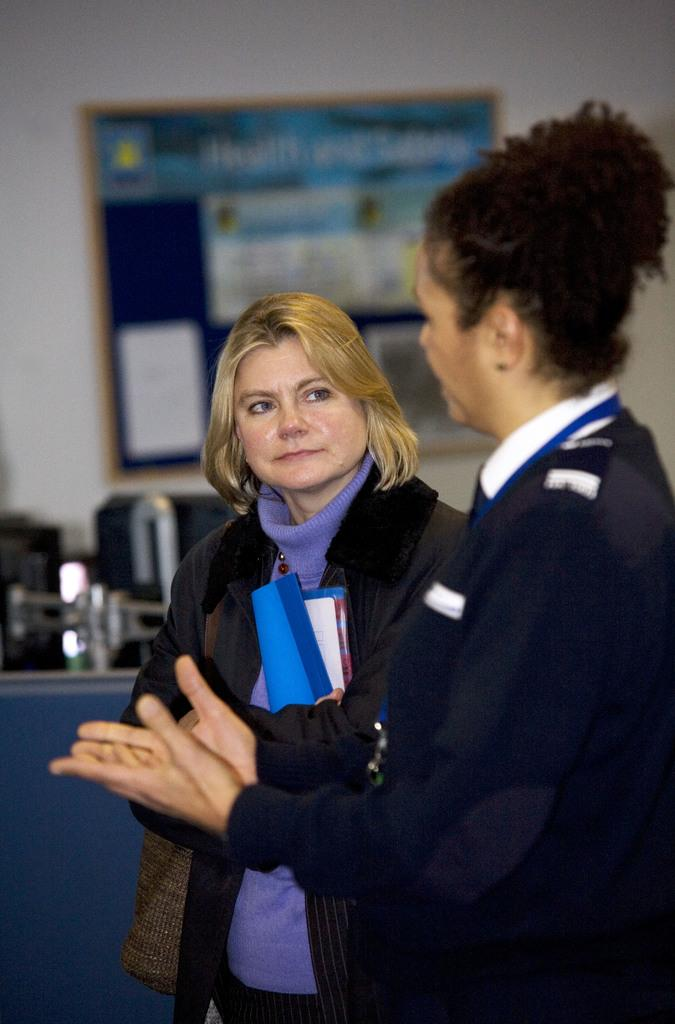How many people are in the image? There are two persons standing in the image. What is one of the persons holding? There is a person holding a book in the image. What can be seen on the wall in the background of the image? There is a frame attached to the wall in the background of the image. What is present on the table in the background of the image? There are items on a table in the background of the image. What type of wine is being served in the image? There is no wine present in the image. How much dirt can be seen on the floor in the image? There is no dirt visible on the floor in the image. 